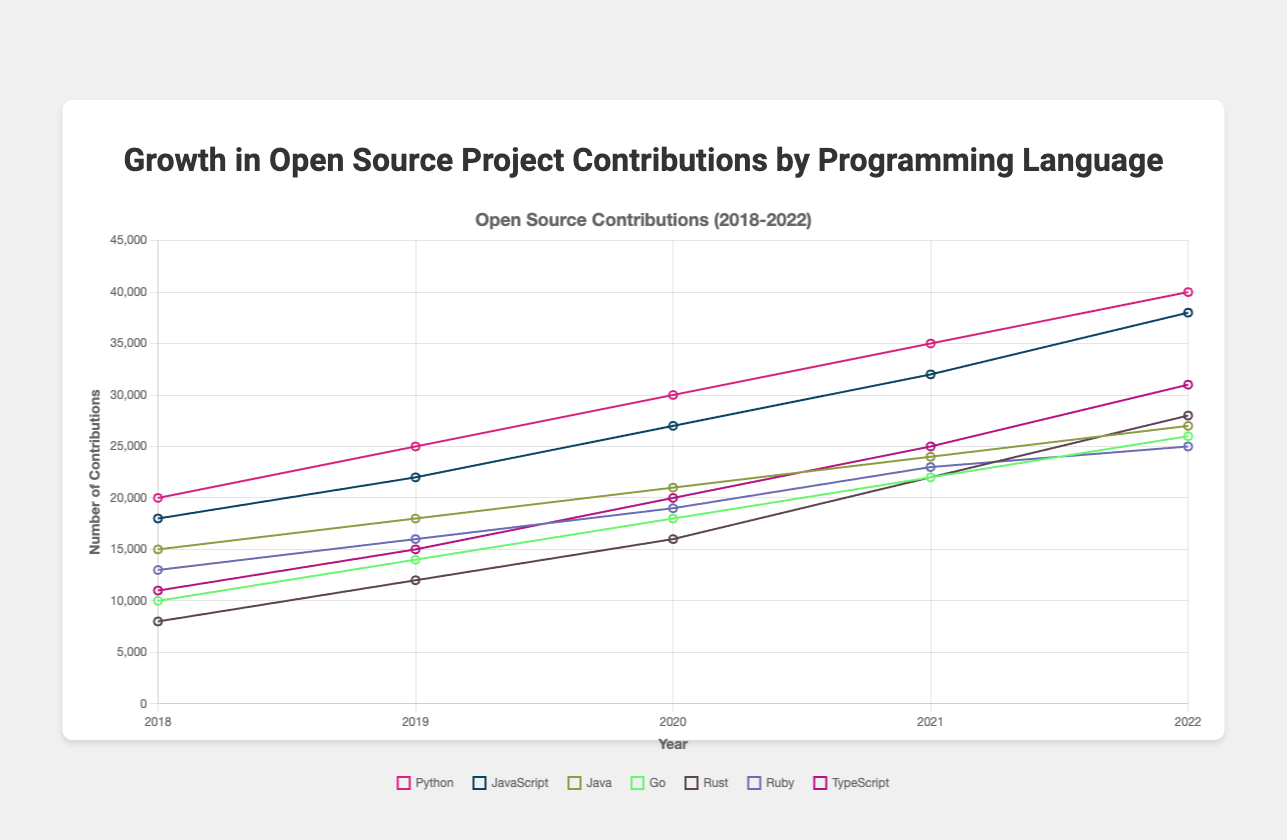Which programming language had the highest growth in contributions between 2018 and 2022? Python had the highest growth in contributions between 2018 and 2022. Python's contributions grew from 20,000 in 2018 to 40,000 in 2022, an increase of 20,000 contributions. No other language had a higher increase in contributions over the same period.
Answer: Python Which programming language had fewer contributions in 2019, JavaScript or Ruby? In 2019, JavaScript had 22,000 contributions while Ruby had 16,000 contributions. Ruby had fewer contributions compared to JavaScript in that year.
Answer: Ruby What is the average number of contributions for Go from 2018 to 2022? The contributions for Go from 2018 to 2022 are 10,000, 14,000, 18,000, 22,000, and 26,000. Adding these values results in a total of 90,000. The average number of contributions is 90,000/5 = 18,000.
Answer: 18,000 Between 2020 and 2021, which language showed a higher percentage growth: Rust or TypeScript? Rust grew from 16,000 contributions in 2020 to 22,000 in 2021, a growth of 6,000 contributions which is a 37.5% increase. TypeScript grew from 20,000 in 2020 to 25,000 in 2021, a growth of 5,000 contributions which is a 25% increase. Hence, Rust showed a higher percentage growth.
Answer: Rust Was Java’s contribution growth from 2019 to 2022 greater than Ruby's and Go's combined growth over the same period? Java's contributions grew from 18,000 in 2019 to 27,000 in 2022, a growth of 9,000. Ruby’s contributions grew from 16,000 in 2019 to 25,000 in 2022, a growth of 9,000. Go’s contributions grew from 14,000 in 2019 to 26,000 in 2022, a growth of 12,000. Combined, Ruby and Go's growth is 9,000 + 12,000 = 21,000, which is greater than Java's growth of 9,000.
Answer: No Which programming language had the least growth in contributions between 2018 and 2022? Java had the least growth in contributions between 2018 and 2022, growing from 15,000 contributions to 27,000, an increase of 12,000 contributions. This is the smallest growth compared to the other languages.
Answer: Java Considering only Python and JavaScript, which year had the closest number of contributions for both languages? In 2019, Python had 25,000 contributions and JavaScript had 22,000 contributions, the difference is 3,000. This is the closest number of contributions for both languages in any year between 2018 and 2022.
Answer: 2019 